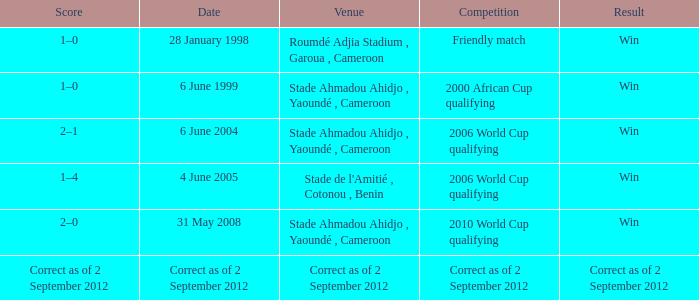What was the result for a friendly match? Win. 